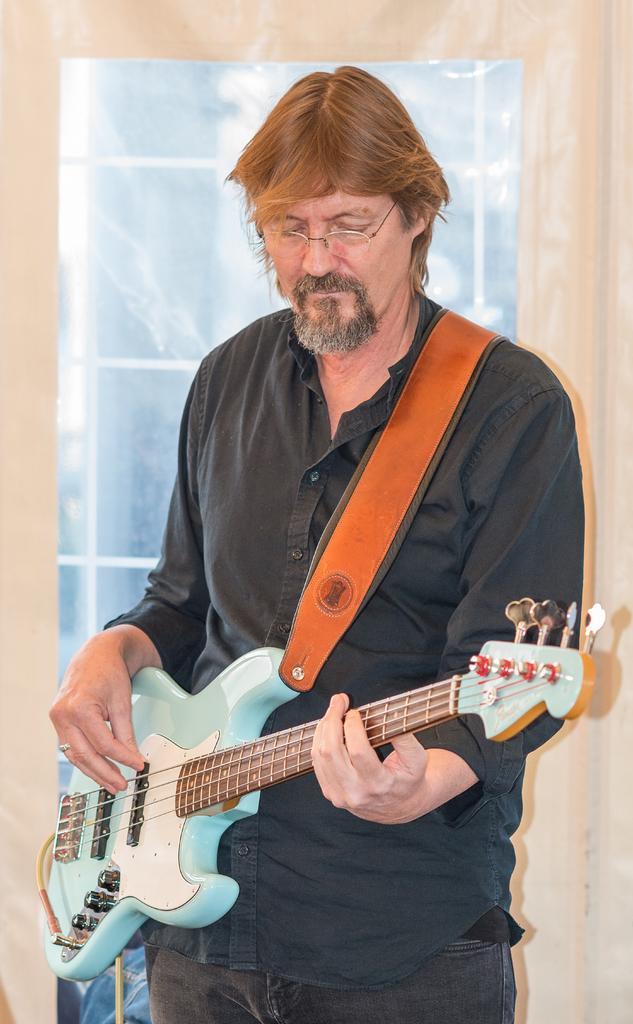What is the main subject of the image? There is a person in the image. What is the person doing in the image? The person is standing and playing a guitar. What type of bean can be seen growing in the image? There is no bean present in the image; it features a person playing a guitar. What direction is the zephyr blowing in the image? There is no mention of a zephyr in the image, as it only shows a person playing a guitar. 